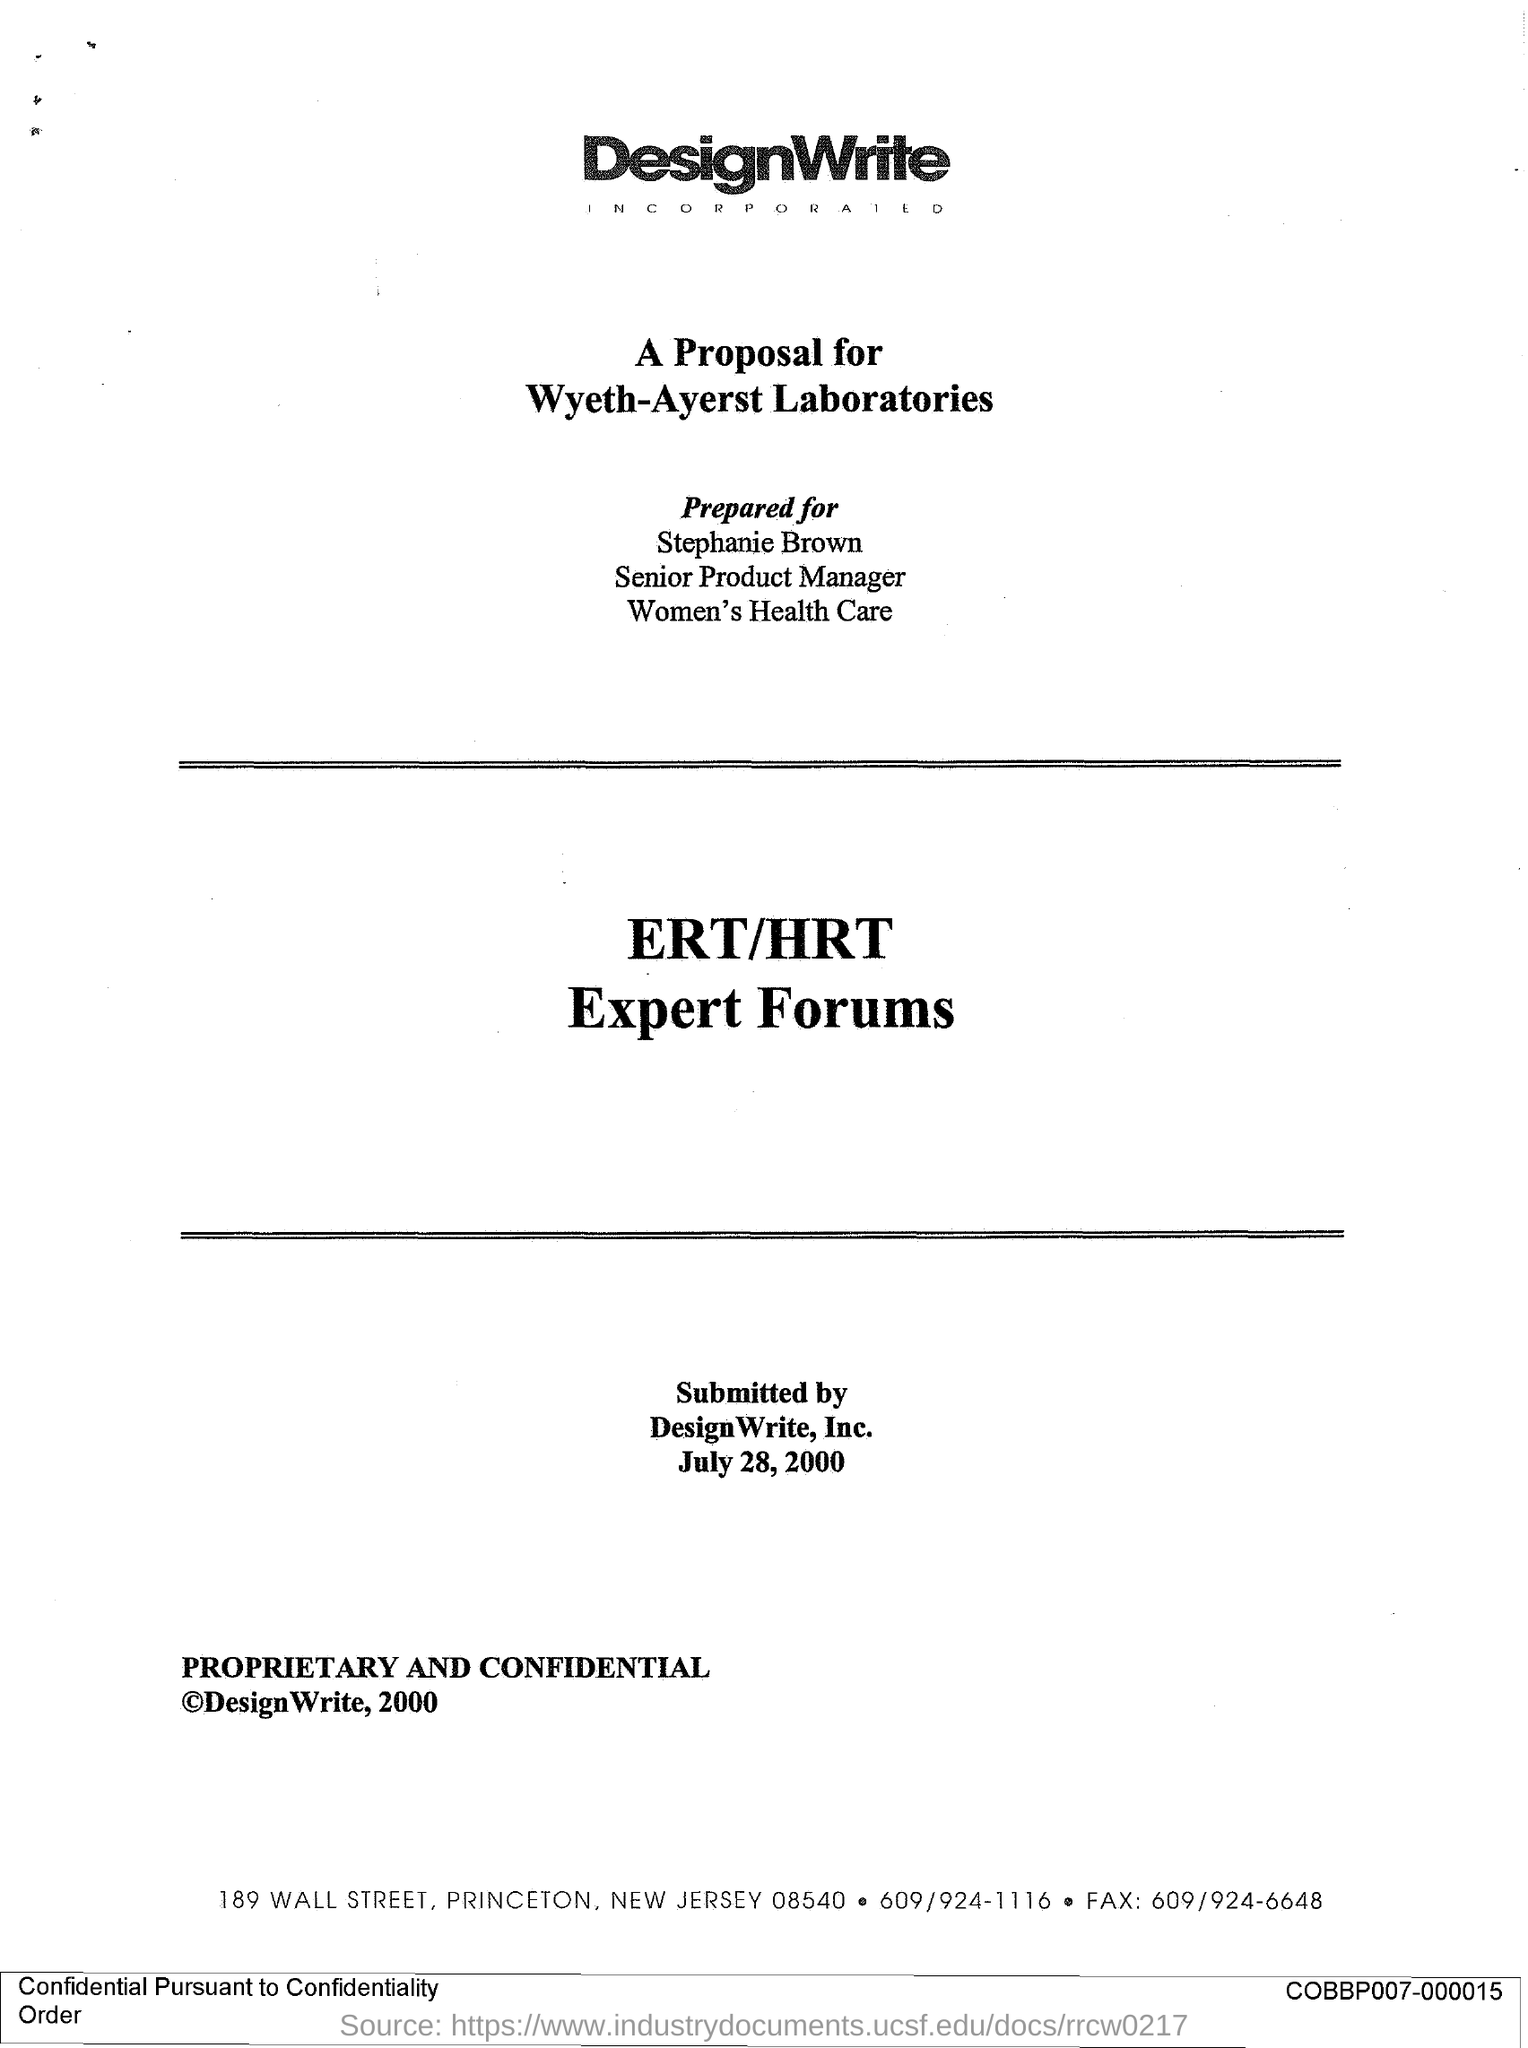Which firm is mentioned at the top of the page?
Offer a very short reply. DesignWrite. What is the proposal about?
Give a very brief answer. ERT/HRT Expert Forums. Who is this prepared for?
Give a very brief answer. Stephanie Brown. What is the title of Stephanie Brown?
Offer a very short reply. Senior Product Manager. Who submitted the proposal?
Offer a terse response. DesignWrite,Inc. When was the proposal submitted?
Provide a succinct answer. July 28, 2000. What is the fax number given?
Give a very brief answer. 609/924-6648. 